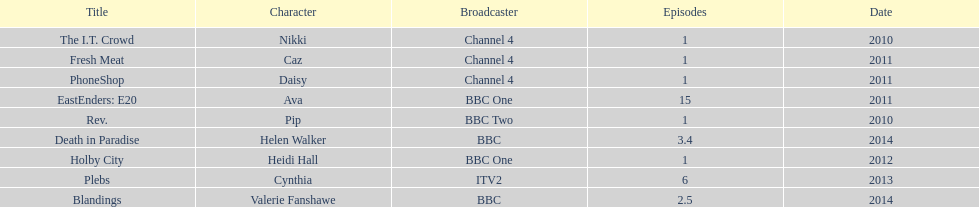Which broadcaster hosted 3 titles but they had only 1 episode? Channel 4. 